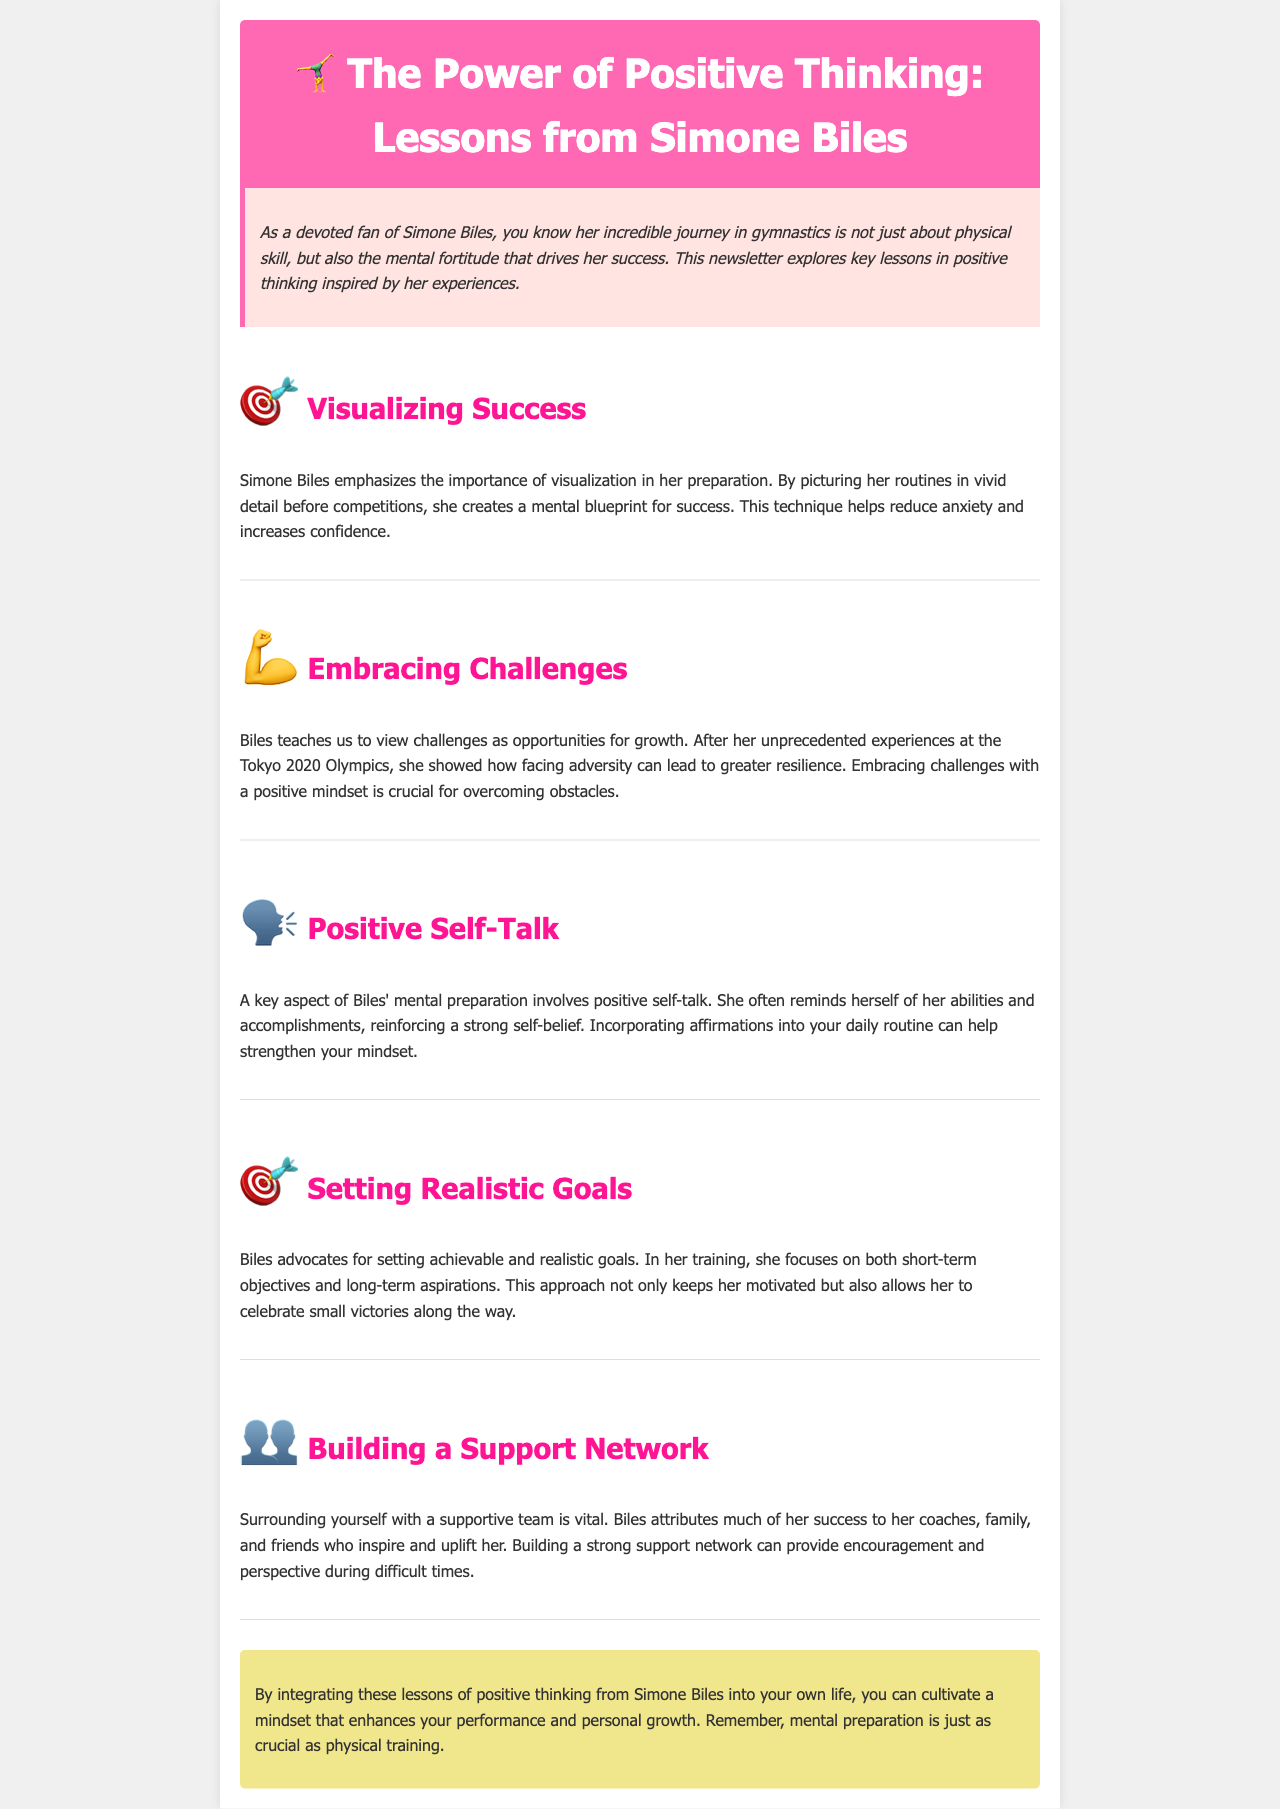What athlete is the focus of this newsletter? The newsletter discusses key lessons in positive thinking inspired by a specific athlete, which is mentioned in the title.
Answer: Simone Biles What is a technique Simone Biles uses to reduce anxiety? The document highlights a specific mental preparation technique used by Biles to increase confidence before competitions.
Answer: Visualization What challenge did Biles face at the Tokyo 2020 Olympics? The newsletter references an experience that sparked an important lesson from Biles about viewing challenges positively.
Answer: Adversity What aspect of mental preparation involves reminding oneself of abilities? The newsletter explains an essential element of Biles' preparation that reinforces self-belief.
Answer: Positive self-talk What type of goals does Biles emphasize in her training? The document outlines the type of objectives Biles believes are important for maintaining motivation and celebrating achievements.
Answer: Realistic goals How does Biles view challenges? The newsletter captures Biles' perspective on challenges, indicating how she categorizes them in her approach to growth.
Answer: Opportunities for growth What supports Biles’ success according to the document? The newsletter notes the importance of a community around Biles that provides encouragement and perspective.
Answer: Support network What is equally important as physical training according to the conclusion? The conclusion emphasizes a crucial aspect that contributes to personal and performance enhancement beyond physical skills.
Answer: Mental preparation 